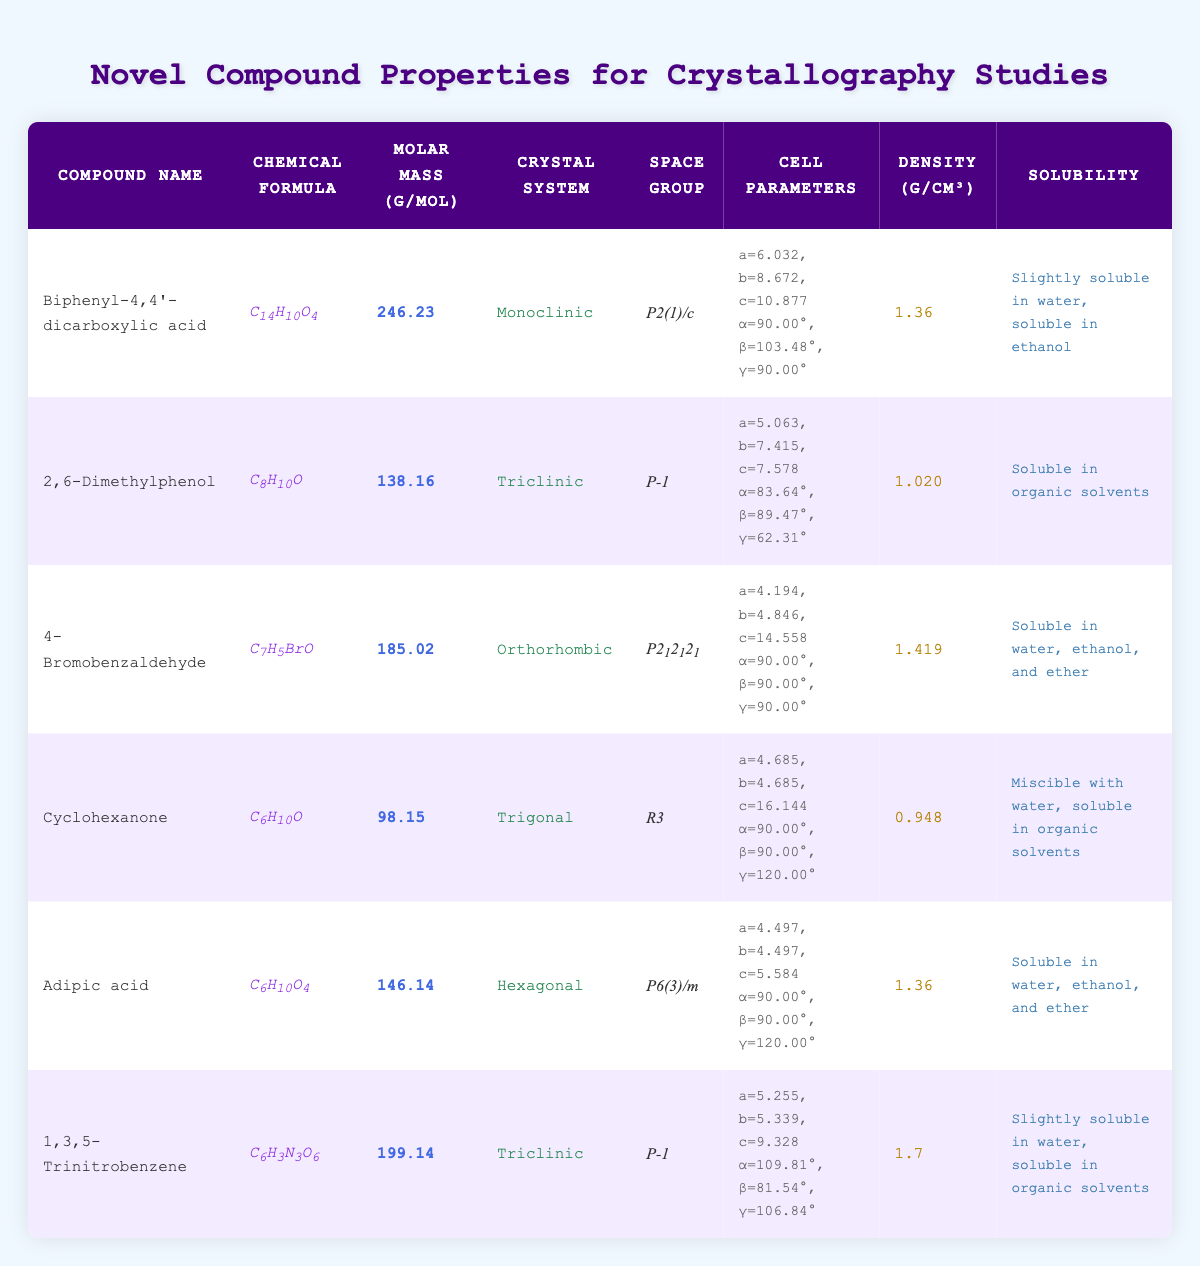What is the molar mass of 1,3,5-Trinitrobenzene? By locating 1,3,5-Trinitrobenzene in the table, we see that its molar mass is listed under the corresponding column. The value given is 199.14 g/mol.
Answer: 199.14 g/mol Which compound has the highest density? The density values for all compounds are listed. By comparing them, we find that 1,3,5-Trinitrobenzene has the highest density at 1.7 g/cm³.
Answer: 1,3,5-Trinitrobenzene What is the chemical formula for Adipic acid? Looking through the table, we can find the row for Adipic acid, where its chemical formula is provided. It is C6H10O4.
Answer: C6H10O4 How many compounds are in the Triclinic crystal system? We check the crystal system column and count the occurrences of Triclinic, which appears for 2,6-Dimethylphenol and 1,3,5-Trinitrobenzene, making a total of 2 compounds.
Answer: 2 What is the solubility of 4-Bromobenzaldehyde? The solubility information for 4-Bromobenzaldehyde can be found in its corresponding row. It states that it is soluble in water, ethanol, and ether.
Answer: Soluble in water, ethanol, and ether What is the average molar mass of compounds in the table? We sum the molar masses: 246.23 + 138.16 + 185.02 + 98.15 + 146.14 + 199.14 = 1,012.84 g/mol. Dividing by the number of compounds (6) gives us an average of approximately 168.81 g/mol.
Answer: 168.81 g/mol Is 2,6-Dimethylphenol slightly soluble in water? Referring to the solubility information for 2,6-Dimethylphenol, it states that it is soluble in organic solvents, but not in water, thus this statement is false.
Answer: No Which compound has the largest 'c' parameter in its cell parameters? By comparing the 'c' parameters within the cell parameters for all compounds: 10.877 (Biphenyl-4,4'-dicarboxylic acid), 7.578 (2,6-Dimethylphenol), 14.558 (4-Bromobenzaldehyde), 16.144 (Cyclohexanone), 5.584 (Adipic acid), and 9.328 (1,3,5-Trinitrobenzene), we find that Cyclohexanone has the largest 'c' parameter of 16.144.
Answer: Cyclohexanone What can be concluded about the solubility of Cyclohexanone based on the table? The table states that Cyclohexanone is miscible with water and soluble in organic solvents, indicating it has favorable solubility characteristics.
Answer: Miscible with water, soluble in organic solvents Which crystal systems are represented in the table? By looking through the crystal system column, we identify Monoclinic, Triclinic, Orthorhombic, Trigonal, and Hexagonal as the crystal systems present in the table.
Answer: Monoclinic, Triclinic, Orthorhombic, Trigonal, Hexagonal 